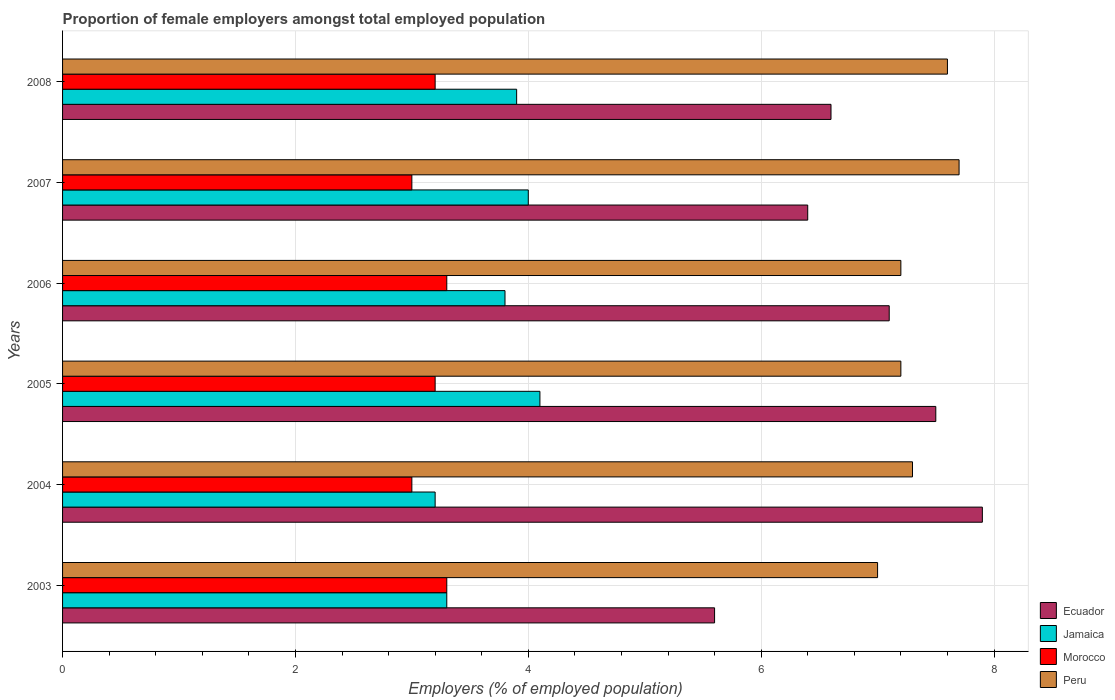How many bars are there on the 4th tick from the top?
Your answer should be very brief. 4. What is the label of the 4th group of bars from the top?
Offer a terse response. 2005. What is the proportion of female employers in Jamaica in 2008?
Keep it short and to the point. 3.9. Across all years, what is the maximum proportion of female employers in Morocco?
Your answer should be compact. 3.3. Across all years, what is the minimum proportion of female employers in Ecuador?
Give a very brief answer. 5.6. What is the total proportion of female employers in Ecuador in the graph?
Offer a very short reply. 41.1. What is the difference between the proportion of female employers in Jamaica in 2007 and that in 2008?
Provide a short and direct response. 0.1. What is the difference between the proportion of female employers in Morocco in 2007 and the proportion of female employers in Peru in 2003?
Make the answer very short. -4. What is the average proportion of female employers in Peru per year?
Keep it short and to the point. 7.33. In the year 2008, what is the difference between the proportion of female employers in Jamaica and proportion of female employers in Peru?
Keep it short and to the point. -3.7. What is the ratio of the proportion of female employers in Peru in 2003 to that in 2007?
Your response must be concise. 0.91. Is the proportion of female employers in Jamaica in 2003 less than that in 2006?
Your answer should be compact. Yes. Is the difference between the proportion of female employers in Jamaica in 2007 and 2008 greater than the difference between the proportion of female employers in Peru in 2007 and 2008?
Offer a terse response. Yes. What is the difference between the highest and the second highest proportion of female employers in Jamaica?
Provide a succinct answer. 0.1. What is the difference between the highest and the lowest proportion of female employers in Jamaica?
Give a very brief answer. 0.9. Is the sum of the proportion of female employers in Jamaica in 2006 and 2008 greater than the maximum proportion of female employers in Ecuador across all years?
Offer a very short reply. No. What does the 3rd bar from the top in 2004 represents?
Give a very brief answer. Jamaica. What does the 1st bar from the bottom in 2003 represents?
Keep it short and to the point. Ecuador. Is it the case that in every year, the sum of the proportion of female employers in Jamaica and proportion of female employers in Peru is greater than the proportion of female employers in Ecuador?
Provide a short and direct response. Yes. What is the difference between two consecutive major ticks on the X-axis?
Provide a short and direct response. 2. Where does the legend appear in the graph?
Keep it short and to the point. Bottom right. What is the title of the graph?
Provide a short and direct response. Proportion of female employers amongst total employed population. What is the label or title of the X-axis?
Ensure brevity in your answer.  Employers (% of employed population). What is the label or title of the Y-axis?
Provide a short and direct response. Years. What is the Employers (% of employed population) in Ecuador in 2003?
Your answer should be compact. 5.6. What is the Employers (% of employed population) in Jamaica in 2003?
Your answer should be compact. 3.3. What is the Employers (% of employed population) in Morocco in 2003?
Offer a very short reply. 3.3. What is the Employers (% of employed population) of Peru in 2003?
Make the answer very short. 7. What is the Employers (% of employed population) in Ecuador in 2004?
Keep it short and to the point. 7.9. What is the Employers (% of employed population) in Jamaica in 2004?
Your response must be concise. 3.2. What is the Employers (% of employed population) in Peru in 2004?
Make the answer very short. 7.3. What is the Employers (% of employed population) in Jamaica in 2005?
Make the answer very short. 4.1. What is the Employers (% of employed population) of Morocco in 2005?
Offer a terse response. 3.2. What is the Employers (% of employed population) in Peru in 2005?
Offer a very short reply. 7.2. What is the Employers (% of employed population) in Ecuador in 2006?
Provide a succinct answer. 7.1. What is the Employers (% of employed population) of Jamaica in 2006?
Give a very brief answer. 3.8. What is the Employers (% of employed population) in Morocco in 2006?
Ensure brevity in your answer.  3.3. What is the Employers (% of employed population) of Peru in 2006?
Keep it short and to the point. 7.2. What is the Employers (% of employed population) in Ecuador in 2007?
Keep it short and to the point. 6.4. What is the Employers (% of employed population) in Peru in 2007?
Give a very brief answer. 7.7. What is the Employers (% of employed population) of Ecuador in 2008?
Your response must be concise. 6.6. What is the Employers (% of employed population) in Jamaica in 2008?
Your answer should be very brief. 3.9. What is the Employers (% of employed population) of Morocco in 2008?
Your answer should be compact. 3.2. What is the Employers (% of employed population) in Peru in 2008?
Make the answer very short. 7.6. Across all years, what is the maximum Employers (% of employed population) of Ecuador?
Provide a succinct answer. 7.9. Across all years, what is the maximum Employers (% of employed population) in Jamaica?
Give a very brief answer. 4.1. Across all years, what is the maximum Employers (% of employed population) in Morocco?
Keep it short and to the point. 3.3. Across all years, what is the maximum Employers (% of employed population) of Peru?
Provide a short and direct response. 7.7. Across all years, what is the minimum Employers (% of employed population) in Ecuador?
Provide a succinct answer. 5.6. Across all years, what is the minimum Employers (% of employed population) of Jamaica?
Your response must be concise. 3.2. Across all years, what is the minimum Employers (% of employed population) in Morocco?
Your answer should be very brief. 3. What is the total Employers (% of employed population) of Ecuador in the graph?
Your response must be concise. 41.1. What is the total Employers (% of employed population) of Jamaica in the graph?
Your answer should be compact. 22.3. What is the difference between the Employers (% of employed population) in Ecuador in 2003 and that in 2004?
Make the answer very short. -2.3. What is the difference between the Employers (% of employed population) in Peru in 2003 and that in 2004?
Offer a very short reply. -0.3. What is the difference between the Employers (% of employed population) of Jamaica in 2003 and that in 2005?
Give a very brief answer. -0.8. What is the difference between the Employers (% of employed population) in Morocco in 2003 and that in 2005?
Keep it short and to the point. 0.1. What is the difference between the Employers (% of employed population) of Peru in 2003 and that in 2005?
Give a very brief answer. -0.2. What is the difference between the Employers (% of employed population) in Ecuador in 2003 and that in 2007?
Keep it short and to the point. -0.8. What is the difference between the Employers (% of employed population) in Jamaica in 2003 and that in 2007?
Your response must be concise. -0.7. What is the difference between the Employers (% of employed population) in Morocco in 2003 and that in 2007?
Keep it short and to the point. 0.3. What is the difference between the Employers (% of employed population) of Ecuador in 2003 and that in 2008?
Keep it short and to the point. -1. What is the difference between the Employers (% of employed population) in Jamaica in 2003 and that in 2008?
Make the answer very short. -0.6. What is the difference between the Employers (% of employed population) of Morocco in 2004 and that in 2005?
Your answer should be very brief. -0.2. What is the difference between the Employers (% of employed population) of Ecuador in 2004 and that in 2006?
Your answer should be very brief. 0.8. What is the difference between the Employers (% of employed population) of Morocco in 2004 and that in 2006?
Offer a very short reply. -0.3. What is the difference between the Employers (% of employed population) in Peru in 2004 and that in 2006?
Offer a very short reply. 0.1. What is the difference between the Employers (% of employed population) of Jamaica in 2004 and that in 2007?
Offer a terse response. -0.8. What is the difference between the Employers (% of employed population) of Morocco in 2004 and that in 2007?
Your answer should be very brief. 0. What is the difference between the Employers (% of employed population) of Ecuador in 2004 and that in 2008?
Offer a very short reply. 1.3. What is the difference between the Employers (% of employed population) of Jamaica in 2004 and that in 2008?
Offer a very short reply. -0.7. What is the difference between the Employers (% of employed population) in Peru in 2005 and that in 2006?
Offer a very short reply. 0. What is the difference between the Employers (% of employed population) in Jamaica in 2005 and that in 2007?
Make the answer very short. 0.1. What is the difference between the Employers (% of employed population) of Morocco in 2005 and that in 2007?
Offer a very short reply. 0.2. What is the difference between the Employers (% of employed population) in Ecuador in 2005 and that in 2008?
Make the answer very short. 0.9. What is the difference between the Employers (% of employed population) in Jamaica in 2005 and that in 2008?
Offer a terse response. 0.2. What is the difference between the Employers (% of employed population) in Peru in 2005 and that in 2008?
Your answer should be very brief. -0.4. What is the difference between the Employers (% of employed population) of Ecuador in 2006 and that in 2007?
Ensure brevity in your answer.  0.7. What is the difference between the Employers (% of employed population) in Morocco in 2006 and that in 2007?
Your answer should be compact. 0.3. What is the difference between the Employers (% of employed population) in Ecuador in 2006 and that in 2008?
Ensure brevity in your answer.  0.5. What is the difference between the Employers (% of employed population) in Jamaica in 2006 and that in 2008?
Offer a terse response. -0.1. What is the difference between the Employers (% of employed population) in Morocco in 2006 and that in 2008?
Your answer should be compact. 0.1. What is the difference between the Employers (% of employed population) of Ecuador in 2007 and that in 2008?
Provide a succinct answer. -0.2. What is the difference between the Employers (% of employed population) in Morocco in 2007 and that in 2008?
Your response must be concise. -0.2. What is the difference between the Employers (% of employed population) in Peru in 2007 and that in 2008?
Offer a terse response. 0.1. What is the difference between the Employers (% of employed population) of Ecuador in 2003 and the Employers (% of employed population) of Peru in 2004?
Make the answer very short. -1.7. What is the difference between the Employers (% of employed population) of Jamaica in 2003 and the Employers (% of employed population) of Morocco in 2004?
Provide a short and direct response. 0.3. What is the difference between the Employers (% of employed population) in Morocco in 2003 and the Employers (% of employed population) in Peru in 2004?
Keep it short and to the point. -4. What is the difference between the Employers (% of employed population) in Ecuador in 2003 and the Employers (% of employed population) in Morocco in 2005?
Your answer should be very brief. 2.4. What is the difference between the Employers (% of employed population) of Morocco in 2003 and the Employers (% of employed population) of Peru in 2005?
Make the answer very short. -3.9. What is the difference between the Employers (% of employed population) of Ecuador in 2003 and the Employers (% of employed population) of Morocco in 2006?
Offer a very short reply. 2.3. What is the difference between the Employers (% of employed population) in Morocco in 2003 and the Employers (% of employed population) in Peru in 2006?
Make the answer very short. -3.9. What is the difference between the Employers (% of employed population) in Ecuador in 2003 and the Employers (% of employed population) in Jamaica in 2007?
Keep it short and to the point. 1.6. What is the difference between the Employers (% of employed population) in Ecuador in 2003 and the Employers (% of employed population) in Morocco in 2007?
Ensure brevity in your answer.  2.6. What is the difference between the Employers (% of employed population) of Ecuador in 2003 and the Employers (% of employed population) of Peru in 2007?
Provide a succinct answer. -2.1. What is the difference between the Employers (% of employed population) in Jamaica in 2003 and the Employers (% of employed population) in Peru in 2007?
Give a very brief answer. -4.4. What is the difference between the Employers (% of employed population) of Morocco in 2003 and the Employers (% of employed population) of Peru in 2007?
Make the answer very short. -4.4. What is the difference between the Employers (% of employed population) of Ecuador in 2003 and the Employers (% of employed population) of Jamaica in 2008?
Offer a terse response. 1.7. What is the difference between the Employers (% of employed population) of Ecuador in 2003 and the Employers (% of employed population) of Peru in 2008?
Give a very brief answer. -2. What is the difference between the Employers (% of employed population) of Morocco in 2003 and the Employers (% of employed population) of Peru in 2008?
Your response must be concise. -4.3. What is the difference between the Employers (% of employed population) of Jamaica in 2004 and the Employers (% of employed population) of Morocco in 2005?
Give a very brief answer. 0. What is the difference between the Employers (% of employed population) of Jamaica in 2004 and the Employers (% of employed population) of Peru in 2005?
Provide a short and direct response. -4. What is the difference between the Employers (% of employed population) in Morocco in 2004 and the Employers (% of employed population) in Peru in 2005?
Provide a succinct answer. -4.2. What is the difference between the Employers (% of employed population) in Ecuador in 2004 and the Employers (% of employed population) in Morocco in 2006?
Ensure brevity in your answer.  4.6. What is the difference between the Employers (% of employed population) in Ecuador in 2004 and the Employers (% of employed population) in Peru in 2006?
Provide a short and direct response. 0.7. What is the difference between the Employers (% of employed population) in Jamaica in 2004 and the Employers (% of employed population) in Peru in 2006?
Provide a short and direct response. -4. What is the difference between the Employers (% of employed population) in Ecuador in 2004 and the Employers (% of employed population) in Morocco in 2007?
Offer a terse response. 4.9. What is the difference between the Employers (% of employed population) of Morocco in 2004 and the Employers (% of employed population) of Peru in 2007?
Your answer should be very brief. -4.7. What is the difference between the Employers (% of employed population) in Jamaica in 2004 and the Employers (% of employed population) in Morocco in 2008?
Make the answer very short. 0. What is the difference between the Employers (% of employed population) in Morocco in 2004 and the Employers (% of employed population) in Peru in 2008?
Your answer should be very brief. -4.6. What is the difference between the Employers (% of employed population) in Ecuador in 2005 and the Employers (% of employed population) in Jamaica in 2006?
Ensure brevity in your answer.  3.7. What is the difference between the Employers (% of employed population) in Ecuador in 2005 and the Employers (% of employed population) in Morocco in 2006?
Make the answer very short. 4.2. What is the difference between the Employers (% of employed population) of Jamaica in 2005 and the Employers (% of employed population) of Morocco in 2006?
Your answer should be very brief. 0.8. What is the difference between the Employers (% of employed population) of Ecuador in 2005 and the Employers (% of employed population) of Jamaica in 2007?
Your answer should be very brief. 3.5. What is the difference between the Employers (% of employed population) of Ecuador in 2005 and the Employers (% of employed population) of Peru in 2007?
Provide a short and direct response. -0.2. What is the difference between the Employers (% of employed population) in Morocco in 2005 and the Employers (% of employed population) in Peru in 2007?
Provide a succinct answer. -4.5. What is the difference between the Employers (% of employed population) of Ecuador in 2005 and the Employers (% of employed population) of Morocco in 2008?
Offer a very short reply. 4.3. What is the difference between the Employers (% of employed population) of Jamaica in 2005 and the Employers (% of employed population) of Morocco in 2008?
Make the answer very short. 0.9. What is the difference between the Employers (% of employed population) of Ecuador in 2006 and the Employers (% of employed population) of Jamaica in 2007?
Offer a very short reply. 3.1. What is the difference between the Employers (% of employed population) of Ecuador in 2006 and the Employers (% of employed population) of Morocco in 2007?
Give a very brief answer. 4.1. What is the difference between the Employers (% of employed population) in Jamaica in 2006 and the Employers (% of employed population) in Morocco in 2007?
Give a very brief answer. 0.8. What is the difference between the Employers (% of employed population) in Ecuador in 2006 and the Employers (% of employed population) in Jamaica in 2008?
Offer a very short reply. 3.2. What is the difference between the Employers (% of employed population) in Jamaica in 2006 and the Employers (% of employed population) in Morocco in 2008?
Make the answer very short. 0.6. What is the difference between the Employers (% of employed population) of Jamaica in 2006 and the Employers (% of employed population) of Peru in 2008?
Provide a succinct answer. -3.8. What is the difference between the Employers (% of employed population) of Morocco in 2006 and the Employers (% of employed population) of Peru in 2008?
Make the answer very short. -4.3. What is the difference between the Employers (% of employed population) in Ecuador in 2007 and the Employers (% of employed population) in Morocco in 2008?
Your answer should be very brief. 3.2. What is the difference between the Employers (% of employed population) of Morocco in 2007 and the Employers (% of employed population) of Peru in 2008?
Provide a succinct answer. -4.6. What is the average Employers (% of employed population) of Ecuador per year?
Provide a succinct answer. 6.85. What is the average Employers (% of employed population) in Jamaica per year?
Your answer should be compact. 3.72. What is the average Employers (% of employed population) of Morocco per year?
Give a very brief answer. 3.17. What is the average Employers (% of employed population) in Peru per year?
Ensure brevity in your answer.  7.33. In the year 2003, what is the difference between the Employers (% of employed population) of Ecuador and Employers (% of employed population) of Jamaica?
Offer a very short reply. 2.3. In the year 2003, what is the difference between the Employers (% of employed population) in Ecuador and Employers (% of employed population) in Morocco?
Keep it short and to the point. 2.3. In the year 2003, what is the difference between the Employers (% of employed population) of Ecuador and Employers (% of employed population) of Peru?
Offer a very short reply. -1.4. In the year 2003, what is the difference between the Employers (% of employed population) of Jamaica and Employers (% of employed population) of Morocco?
Provide a succinct answer. 0. In the year 2003, what is the difference between the Employers (% of employed population) in Morocco and Employers (% of employed population) in Peru?
Provide a succinct answer. -3.7. In the year 2004, what is the difference between the Employers (% of employed population) in Ecuador and Employers (% of employed population) in Peru?
Make the answer very short. 0.6. In the year 2004, what is the difference between the Employers (% of employed population) in Jamaica and Employers (% of employed population) in Morocco?
Provide a short and direct response. 0.2. In the year 2005, what is the difference between the Employers (% of employed population) in Ecuador and Employers (% of employed population) in Jamaica?
Offer a very short reply. 3.4. In the year 2005, what is the difference between the Employers (% of employed population) of Ecuador and Employers (% of employed population) of Morocco?
Offer a very short reply. 4.3. In the year 2005, what is the difference between the Employers (% of employed population) in Jamaica and Employers (% of employed population) in Morocco?
Your response must be concise. 0.9. In the year 2005, what is the difference between the Employers (% of employed population) in Jamaica and Employers (% of employed population) in Peru?
Offer a very short reply. -3.1. In the year 2005, what is the difference between the Employers (% of employed population) of Morocco and Employers (% of employed population) of Peru?
Give a very brief answer. -4. In the year 2006, what is the difference between the Employers (% of employed population) of Ecuador and Employers (% of employed population) of Peru?
Give a very brief answer. -0.1. In the year 2006, what is the difference between the Employers (% of employed population) in Jamaica and Employers (% of employed population) in Peru?
Ensure brevity in your answer.  -3.4. In the year 2006, what is the difference between the Employers (% of employed population) in Morocco and Employers (% of employed population) in Peru?
Your response must be concise. -3.9. In the year 2007, what is the difference between the Employers (% of employed population) in Ecuador and Employers (% of employed population) in Jamaica?
Your answer should be very brief. 2.4. In the year 2007, what is the difference between the Employers (% of employed population) of Ecuador and Employers (% of employed population) of Morocco?
Ensure brevity in your answer.  3.4. In the year 2008, what is the difference between the Employers (% of employed population) in Ecuador and Employers (% of employed population) in Morocco?
Make the answer very short. 3.4. In the year 2008, what is the difference between the Employers (% of employed population) of Ecuador and Employers (% of employed population) of Peru?
Offer a very short reply. -1. In the year 2008, what is the difference between the Employers (% of employed population) of Morocco and Employers (% of employed population) of Peru?
Your answer should be very brief. -4.4. What is the ratio of the Employers (% of employed population) in Ecuador in 2003 to that in 2004?
Provide a short and direct response. 0.71. What is the ratio of the Employers (% of employed population) of Jamaica in 2003 to that in 2004?
Your answer should be compact. 1.03. What is the ratio of the Employers (% of employed population) in Morocco in 2003 to that in 2004?
Your answer should be very brief. 1.1. What is the ratio of the Employers (% of employed population) in Peru in 2003 to that in 2004?
Keep it short and to the point. 0.96. What is the ratio of the Employers (% of employed population) of Ecuador in 2003 to that in 2005?
Provide a short and direct response. 0.75. What is the ratio of the Employers (% of employed population) in Jamaica in 2003 to that in 2005?
Provide a short and direct response. 0.8. What is the ratio of the Employers (% of employed population) in Morocco in 2003 to that in 2005?
Make the answer very short. 1.03. What is the ratio of the Employers (% of employed population) in Peru in 2003 to that in 2005?
Your response must be concise. 0.97. What is the ratio of the Employers (% of employed population) in Ecuador in 2003 to that in 2006?
Give a very brief answer. 0.79. What is the ratio of the Employers (% of employed population) in Jamaica in 2003 to that in 2006?
Give a very brief answer. 0.87. What is the ratio of the Employers (% of employed population) of Peru in 2003 to that in 2006?
Provide a short and direct response. 0.97. What is the ratio of the Employers (% of employed population) of Ecuador in 2003 to that in 2007?
Offer a very short reply. 0.88. What is the ratio of the Employers (% of employed population) in Jamaica in 2003 to that in 2007?
Your answer should be compact. 0.82. What is the ratio of the Employers (% of employed population) in Ecuador in 2003 to that in 2008?
Provide a succinct answer. 0.85. What is the ratio of the Employers (% of employed population) in Jamaica in 2003 to that in 2008?
Make the answer very short. 0.85. What is the ratio of the Employers (% of employed population) in Morocco in 2003 to that in 2008?
Provide a succinct answer. 1.03. What is the ratio of the Employers (% of employed population) of Peru in 2003 to that in 2008?
Make the answer very short. 0.92. What is the ratio of the Employers (% of employed population) in Ecuador in 2004 to that in 2005?
Your answer should be very brief. 1.05. What is the ratio of the Employers (% of employed population) of Jamaica in 2004 to that in 2005?
Keep it short and to the point. 0.78. What is the ratio of the Employers (% of employed population) of Morocco in 2004 to that in 2005?
Your answer should be compact. 0.94. What is the ratio of the Employers (% of employed population) of Peru in 2004 to that in 2005?
Your answer should be compact. 1.01. What is the ratio of the Employers (% of employed population) of Ecuador in 2004 to that in 2006?
Your response must be concise. 1.11. What is the ratio of the Employers (% of employed population) in Jamaica in 2004 to that in 2006?
Provide a short and direct response. 0.84. What is the ratio of the Employers (% of employed population) of Morocco in 2004 to that in 2006?
Provide a short and direct response. 0.91. What is the ratio of the Employers (% of employed population) of Peru in 2004 to that in 2006?
Give a very brief answer. 1.01. What is the ratio of the Employers (% of employed population) in Ecuador in 2004 to that in 2007?
Keep it short and to the point. 1.23. What is the ratio of the Employers (% of employed population) in Jamaica in 2004 to that in 2007?
Ensure brevity in your answer.  0.8. What is the ratio of the Employers (% of employed population) in Morocco in 2004 to that in 2007?
Your answer should be very brief. 1. What is the ratio of the Employers (% of employed population) in Peru in 2004 to that in 2007?
Make the answer very short. 0.95. What is the ratio of the Employers (% of employed population) of Ecuador in 2004 to that in 2008?
Offer a terse response. 1.2. What is the ratio of the Employers (% of employed population) of Jamaica in 2004 to that in 2008?
Provide a succinct answer. 0.82. What is the ratio of the Employers (% of employed population) of Morocco in 2004 to that in 2008?
Ensure brevity in your answer.  0.94. What is the ratio of the Employers (% of employed population) in Peru in 2004 to that in 2008?
Your response must be concise. 0.96. What is the ratio of the Employers (% of employed population) in Ecuador in 2005 to that in 2006?
Your response must be concise. 1.06. What is the ratio of the Employers (% of employed population) of Jamaica in 2005 to that in 2006?
Provide a succinct answer. 1.08. What is the ratio of the Employers (% of employed population) in Morocco in 2005 to that in 2006?
Your answer should be very brief. 0.97. What is the ratio of the Employers (% of employed population) in Ecuador in 2005 to that in 2007?
Ensure brevity in your answer.  1.17. What is the ratio of the Employers (% of employed population) in Jamaica in 2005 to that in 2007?
Make the answer very short. 1.02. What is the ratio of the Employers (% of employed population) of Morocco in 2005 to that in 2007?
Your response must be concise. 1.07. What is the ratio of the Employers (% of employed population) of Peru in 2005 to that in 2007?
Offer a terse response. 0.94. What is the ratio of the Employers (% of employed population) in Ecuador in 2005 to that in 2008?
Your response must be concise. 1.14. What is the ratio of the Employers (% of employed population) of Jamaica in 2005 to that in 2008?
Provide a succinct answer. 1.05. What is the ratio of the Employers (% of employed population) in Morocco in 2005 to that in 2008?
Provide a succinct answer. 1. What is the ratio of the Employers (% of employed population) in Peru in 2005 to that in 2008?
Make the answer very short. 0.95. What is the ratio of the Employers (% of employed population) in Ecuador in 2006 to that in 2007?
Provide a short and direct response. 1.11. What is the ratio of the Employers (% of employed population) of Morocco in 2006 to that in 2007?
Ensure brevity in your answer.  1.1. What is the ratio of the Employers (% of employed population) in Peru in 2006 to that in 2007?
Ensure brevity in your answer.  0.94. What is the ratio of the Employers (% of employed population) in Ecuador in 2006 to that in 2008?
Your answer should be very brief. 1.08. What is the ratio of the Employers (% of employed population) of Jamaica in 2006 to that in 2008?
Give a very brief answer. 0.97. What is the ratio of the Employers (% of employed population) in Morocco in 2006 to that in 2008?
Your answer should be compact. 1.03. What is the ratio of the Employers (% of employed population) of Peru in 2006 to that in 2008?
Offer a very short reply. 0.95. What is the ratio of the Employers (% of employed population) in Ecuador in 2007 to that in 2008?
Provide a short and direct response. 0.97. What is the ratio of the Employers (% of employed population) of Jamaica in 2007 to that in 2008?
Ensure brevity in your answer.  1.03. What is the ratio of the Employers (% of employed population) in Morocco in 2007 to that in 2008?
Your answer should be compact. 0.94. What is the ratio of the Employers (% of employed population) in Peru in 2007 to that in 2008?
Provide a short and direct response. 1.01. What is the difference between the highest and the second highest Employers (% of employed population) in Ecuador?
Ensure brevity in your answer.  0.4. What is the difference between the highest and the second highest Employers (% of employed population) in Jamaica?
Provide a succinct answer. 0.1. What is the difference between the highest and the lowest Employers (% of employed population) of Jamaica?
Your response must be concise. 0.9. What is the difference between the highest and the lowest Employers (% of employed population) of Morocco?
Provide a succinct answer. 0.3. What is the difference between the highest and the lowest Employers (% of employed population) of Peru?
Offer a terse response. 0.7. 